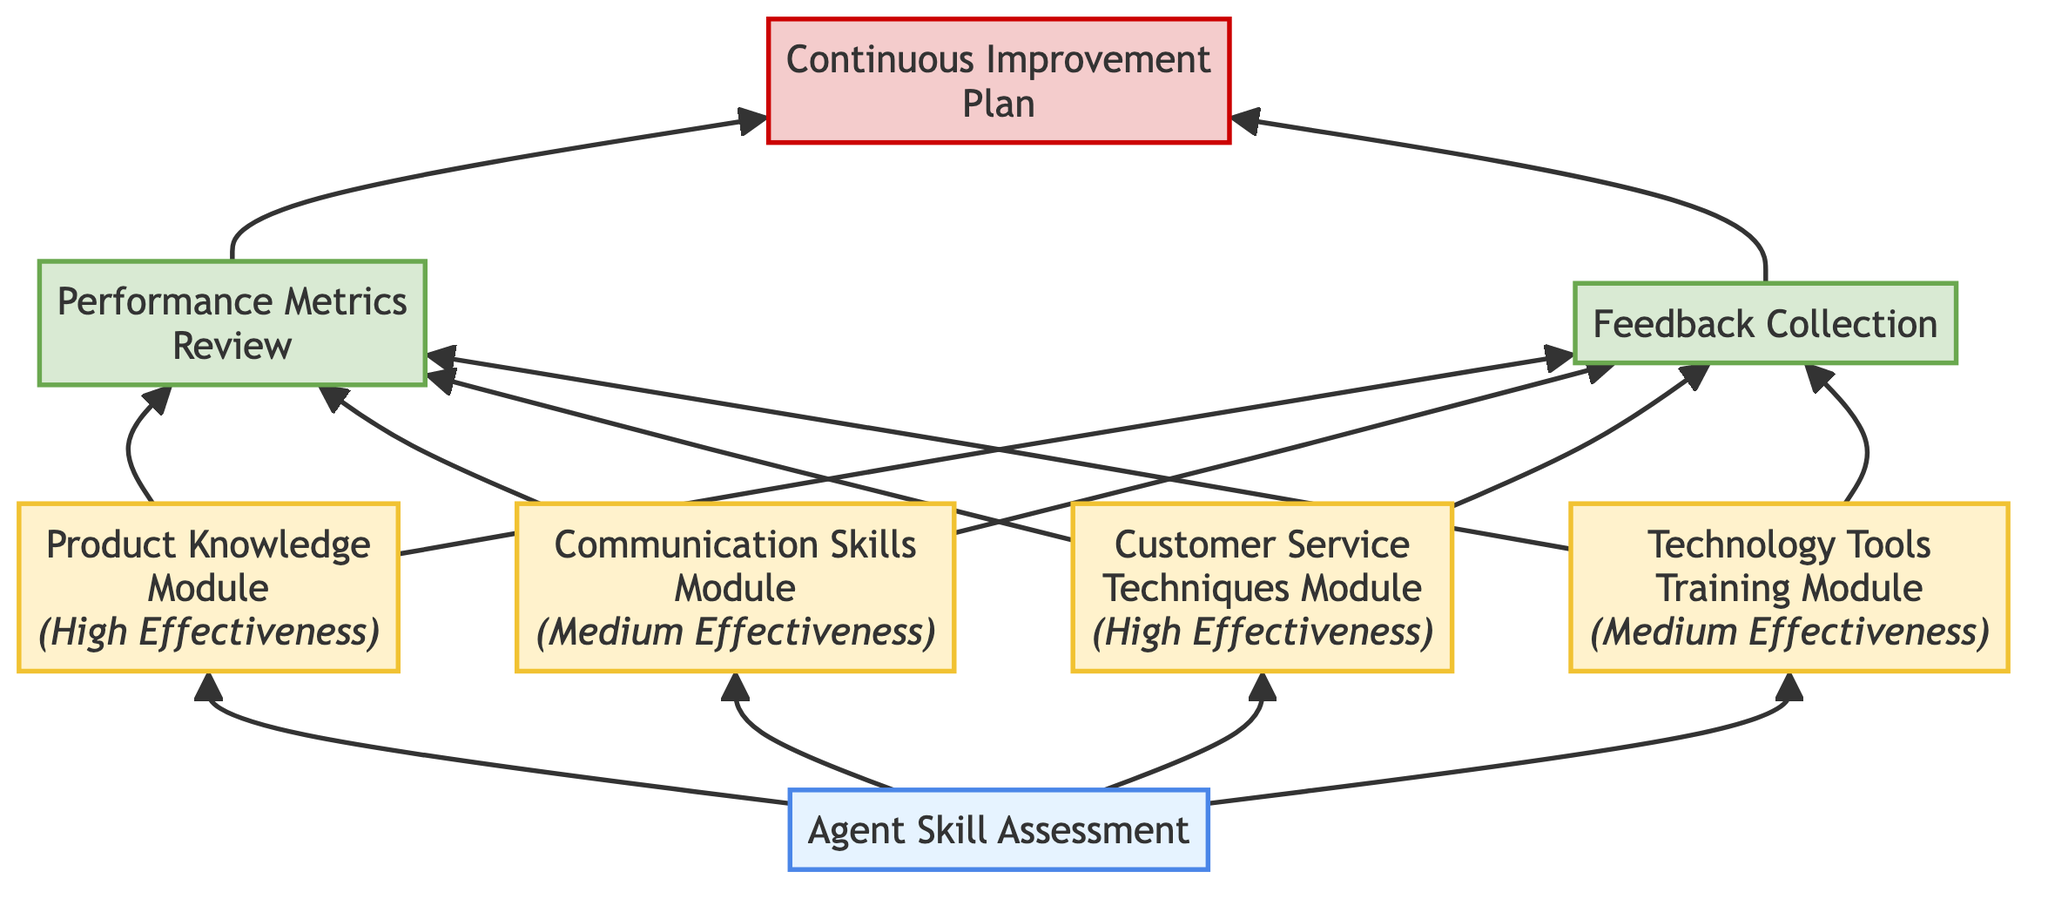What is the first step in the training program evaluation? The diagram starts with "Agent Skill Assessment" as the first element, indicating the initial step in evaluating the agents’ training needs.
Answer: Agent Skill Assessment How many training modules are included in the diagram? By counting the training modules presented in the diagram, there are four: Product Knowledge Module, Communication Skills Module, Customer Service Techniques Module, and Technology Tools Training Module.
Answer: 4 Which module has the highest effectiveness? The diagram specifies the "Product Knowledge Module" and "Customer Service Techniques Module," both labeled as "High Effectiveness," indicating these two modules have the highest effectiveness.
Answer: Product Knowledge Module, Customer Service Techniques Module What comes after the training modules in the flowchart? Following the training modules, the outputs "Performance Metrics Review" and "Feedback Collection" are next in the flowchart.
Answer: Performance Metrics Review, Feedback Collection What is the purpose of the "Continuous Improvement Plan"? The "Continuous Improvement Plan" is designed to refine training programs based on the evaluations from "Performance Metrics Review" and "Feedback Collection," showcasing its role in ongoing refinement.
Answer: Adjustment of training programs Which module focuses on communication skills? The "Communication Skills Module" directly addresses the aim of improving both verbal and written communication talents, making it the specific module focusing on this area.
Answer: Communication Skills Module How is the effectiveness of the "Technology Tools Training Module" described? The effectiveness of the "Technology Tools Training Module" is labeled as "Medium," indicating a moderate level of effectiveness according to the diagram.
Answer: Medium Which outputs are generated after the training modules are completed? After the completion of the training modules, the outputs are "Performance Metrics Review" and "Feedback Collection," both highlighted in the flowchart.
Answer: Performance Metrics Review, Feedback Collection How do the outputs connect to the continuous improvement process? The diagram shows that both outputs, "Performance Metrics Review" and "Feedback Collection," feed into the "Continuous Improvement Plan," indicating how they are used for refining the training program.
Answer: They lead to "Continuous Improvement Plan" 